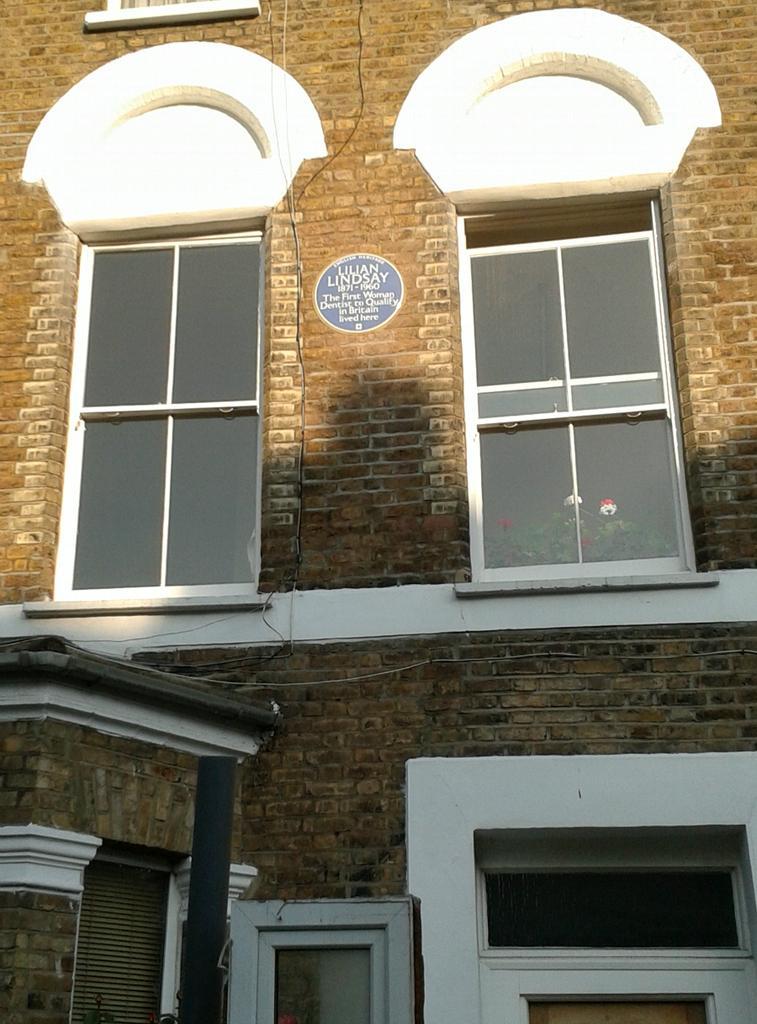Can you describe this image briefly? In the image we can see a building, on the building there are some windows. 